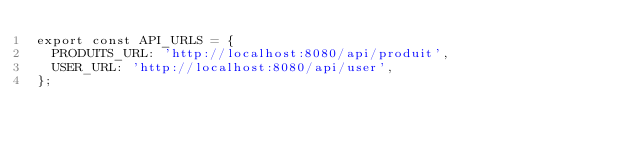<code> <loc_0><loc_0><loc_500><loc_500><_TypeScript_>export const API_URLS = {
  PRODUITS_URL: 'http://localhost:8080/api/produit',
  USER_URL: 'http://localhost:8080/api/user',
};
</code> 